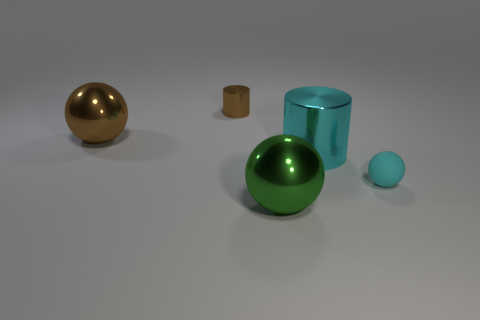Are there more brown metallic spheres than tiny yellow matte balls?
Your response must be concise. Yes. How many things are either brown objects to the left of the brown cylinder or brown spheres that are left of the green shiny ball?
Offer a terse response. 1. What is the color of the metal cylinder that is the same size as the green ball?
Your answer should be very brief. Cyan. Is the material of the large green object the same as the small cyan object?
Offer a very short reply. No. There is a big sphere left of the small object behind the cyan ball; what is it made of?
Offer a terse response. Metal. Are there more large green things that are on the right side of the large green sphere than small cyan balls?
Ensure brevity in your answer.  No. How many other objects are there of the same size as the green object?
Provide a succinct answer. 2. Does the small sphere have the same color as the small metal thing?
Give a very brief answer. No. There is a small thing in front of the cyan object left of the tiny object to the right of the big green sphere; what is its color?
Ensure brevity in your answer.  Cyan. What number of cylinders are on the left side of the ball on the left side of the big metallic object in front of the tiny cyan thing?
Your answer should be very brief. 0. 